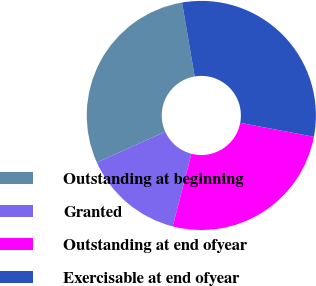Convert chart to OTSL. <chart><loc_0><loc_0><loc_500><loc_500><pie_chart><fcel>Outstanding at beginning<fcel>Granted<fcel>Outstanding at end ofyear<fcel>Exercisable at end ofyear<nl><fcel>29.04%<fcel>14.25%<fcel>26.04%<fcel>30.67%<nl></chart> 